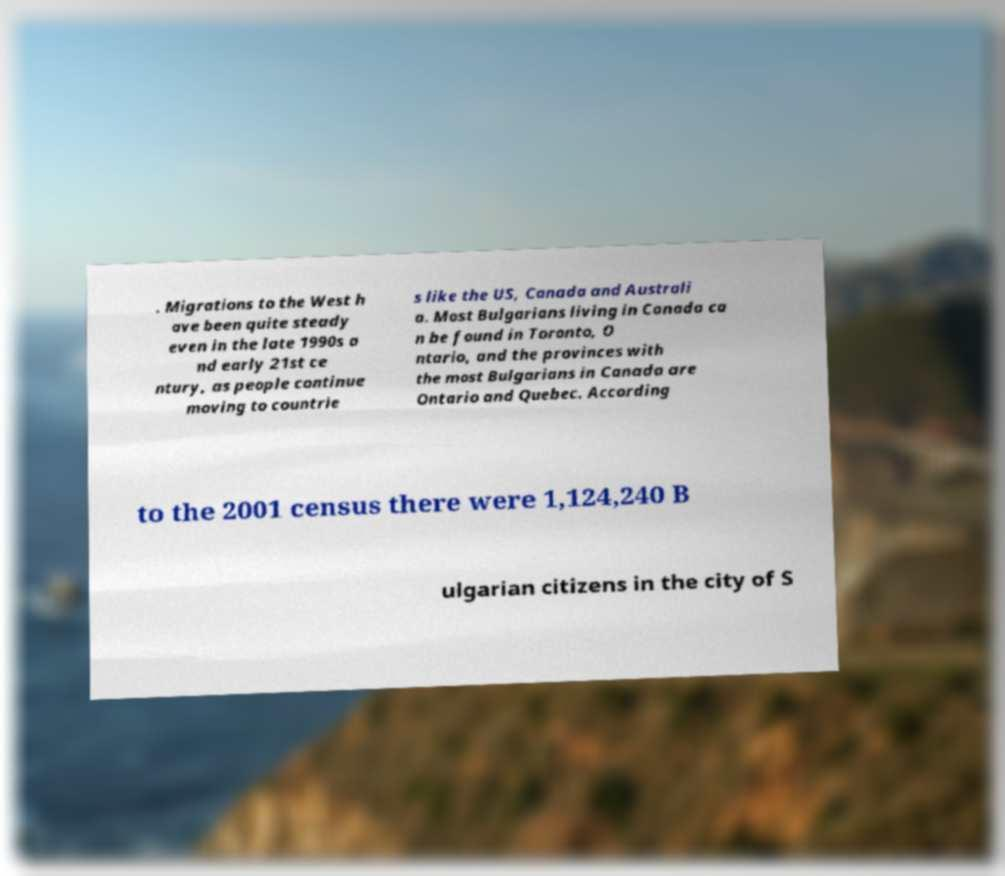Please read and relay the text visible in this image. What does it say? . Migrations to the West h ave been quite steady even in the late 1990s a nd early 21st ce ntury, as people continue moving to countrie s like the US, Canada and Australi a. Most Bulgarians living in Canada ca n be found in Toronto, O ntario, and the provinces with the most Bulgarians in Canada are Ontario and Quebec. According to the 2001 census there were 1,124,240 B ulgarian citizens in the city of S 